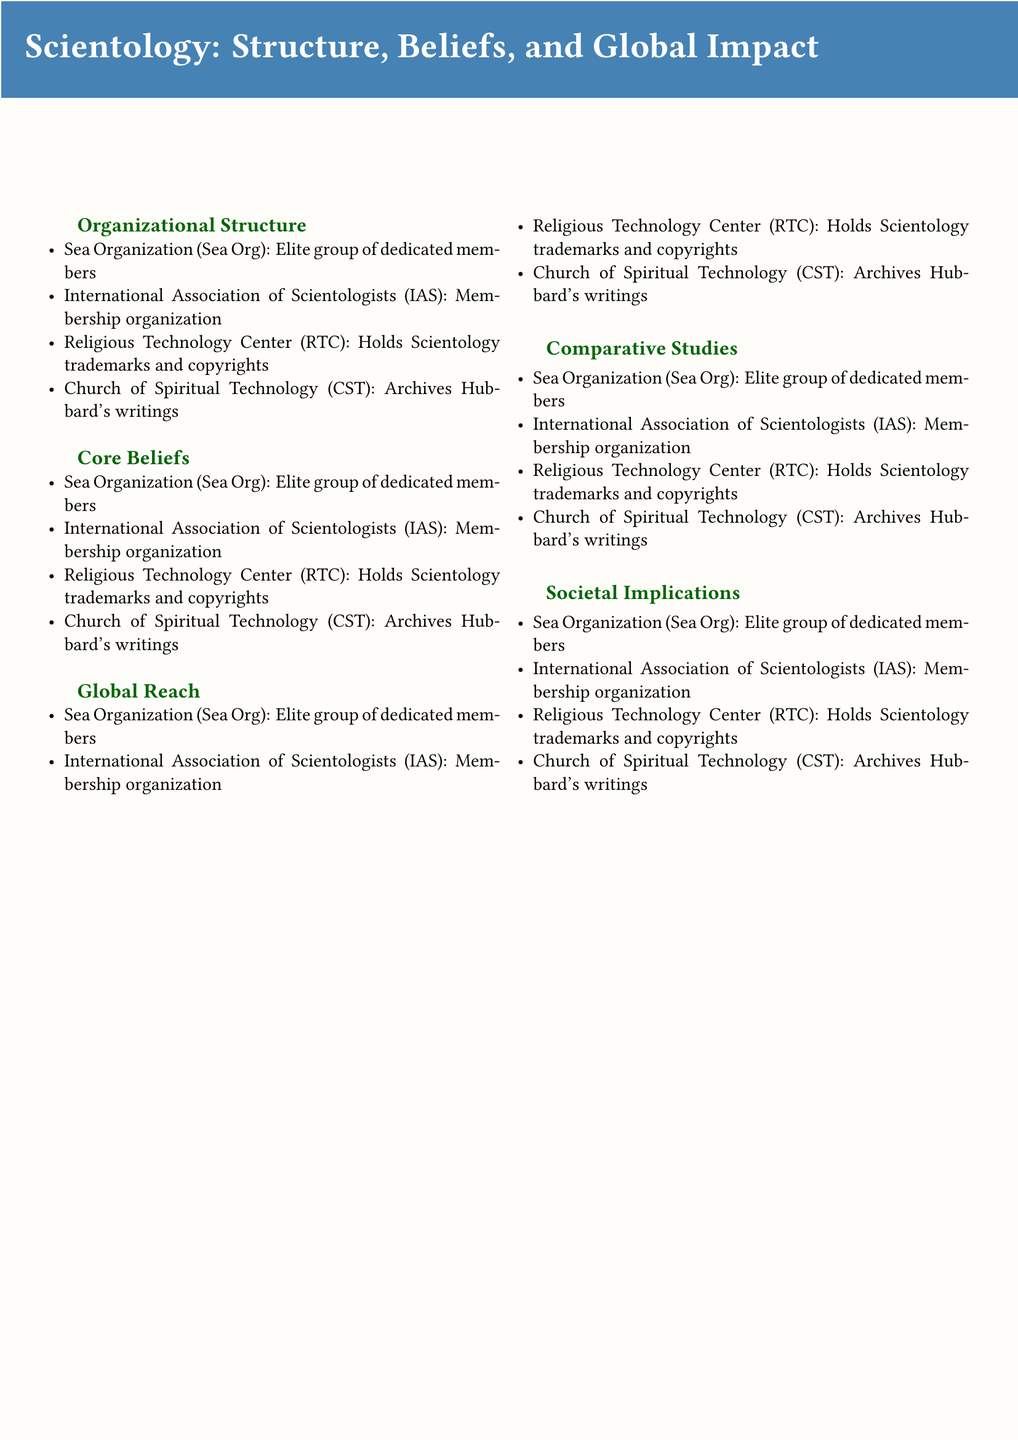what is the elite group of dedicated members in Scientology called? The document states that the elite group of dedicated members is known as the Sea Organization (Sea Org).
Answer: Sea Organization (Sea Org) what does the term 'Thetan' refer to in Scientology? According to the document, 'Thetan' refers to the immortal spiritual being in Scientology beliefs.
Answer: Immortal spiritual being what organization holds Scientology trademarks and copyrights? The document identifies the Religious Technology Center (RTC) as the organization that holds Scientology trademarks and copyrights.
Answer: Religious Technology Center (RTC) which educational program is associated with Scientology? The document lists Applied Scholastics as the educational program associated with Scientology.
Answer: Applied Scholastics how does Scientology's focus on self-improvement differ from traditional religions? The document notes that Scientology emphasizes self-improvement, which is a key difference from traditional religions.
Answer: Emphasis on self-improvement what similarity does Scientology have with Eastern philosophies? The document mentions similarities regarding the reincarnation concepts found in both Scientology and Eastern philosophies.
Answer: Reincarnation concepts how many advanced spiritual states are referred to as Operating Thetan levels in Scientology? The document indicates that Operating Thetan levels are part of the Scientology belief system, corresponding to advanced spiritual states without specifying a number.
Answer: Advanced spiritual states what is one program Scientology runs related to drug rehabilitation? According to the document, Narconon is the program that Scientology runs related to drug rehabilitation.
Answer: Narconon what impact does ex-member activism have according to the document? The document outlines that ex-member activism has an impact on public perception and policy regarding Scientology.
Answer: Impact on public perception and policy 